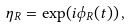Convert formula to latex. <formula><loc_0><loc_0><loc_500><loc_500>\eta _ { R } = \exp ( i \phi _ { R } ( t ) ) \, ,</formula> 